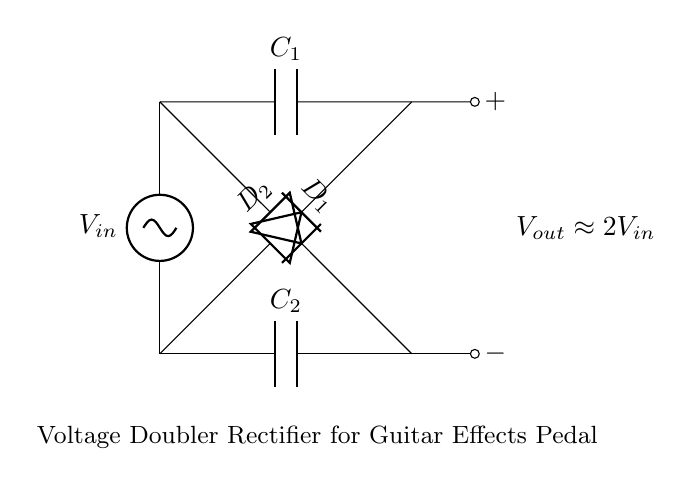What is the input voltage symbol in this circuit? The input voltage is represented as \( V_{in} \), which is the designation for the initial AC voltage supplied to the circuit.
Answer: \( V_{in} \) How many diodes are used in this rectifier circuit? The circuit contains two diodes, labelled \( D_1 \) and \( D_2 \), which play a critical role in converting the AC input to a pulsed DC output.
Answer: 2 What is the relationship between output voltage and input voltage? The output voltage \( V_{out} \) is approximately double the input voltage \( V_{in} \), as indicated in the label on the right side of the diagram. This shows that this circuit functions as a voltage doubler.
Answer: Approximately 2 times \( V_{in} \) Which components are used to store charge in this circuit? The circuit includes two capacitors, labelled \( C_1 \) and \( C_2 \), which are responsible for temporarily storing electrical charge to smooth out the output voltage.
Answer: \( C_1 \) and \( C_2 \) What type of rectifier is this circuit implementing? The circuit is implementing a voltage doubler rectifier, specifically designed to increase the output voltage from an AC source by utilizing the configuration of the diodes and capacitors.
Answer: Voltage doubler rectifier Explain the purpose of the diodes in this circuit. The diodes \( D_1 \) and \( D_2 \) are used to control the direction of current flow, allowing current to pass during certain portions of the AC cycle while blocking it during others, which enables the conversion from AC to pulsating DC.
Answer: Control current flow for rectification 